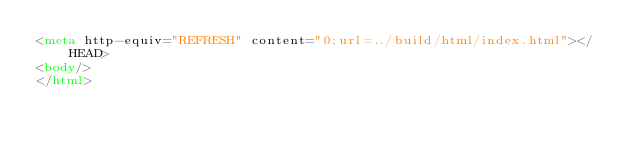<code> <loc_0><loc_0><loc_500><loc_500><_HTML_><meta http-equiv="REFRESH" content="0;url=../build/html/index.html"></HEAD>
<body/>
</html>
</code> 